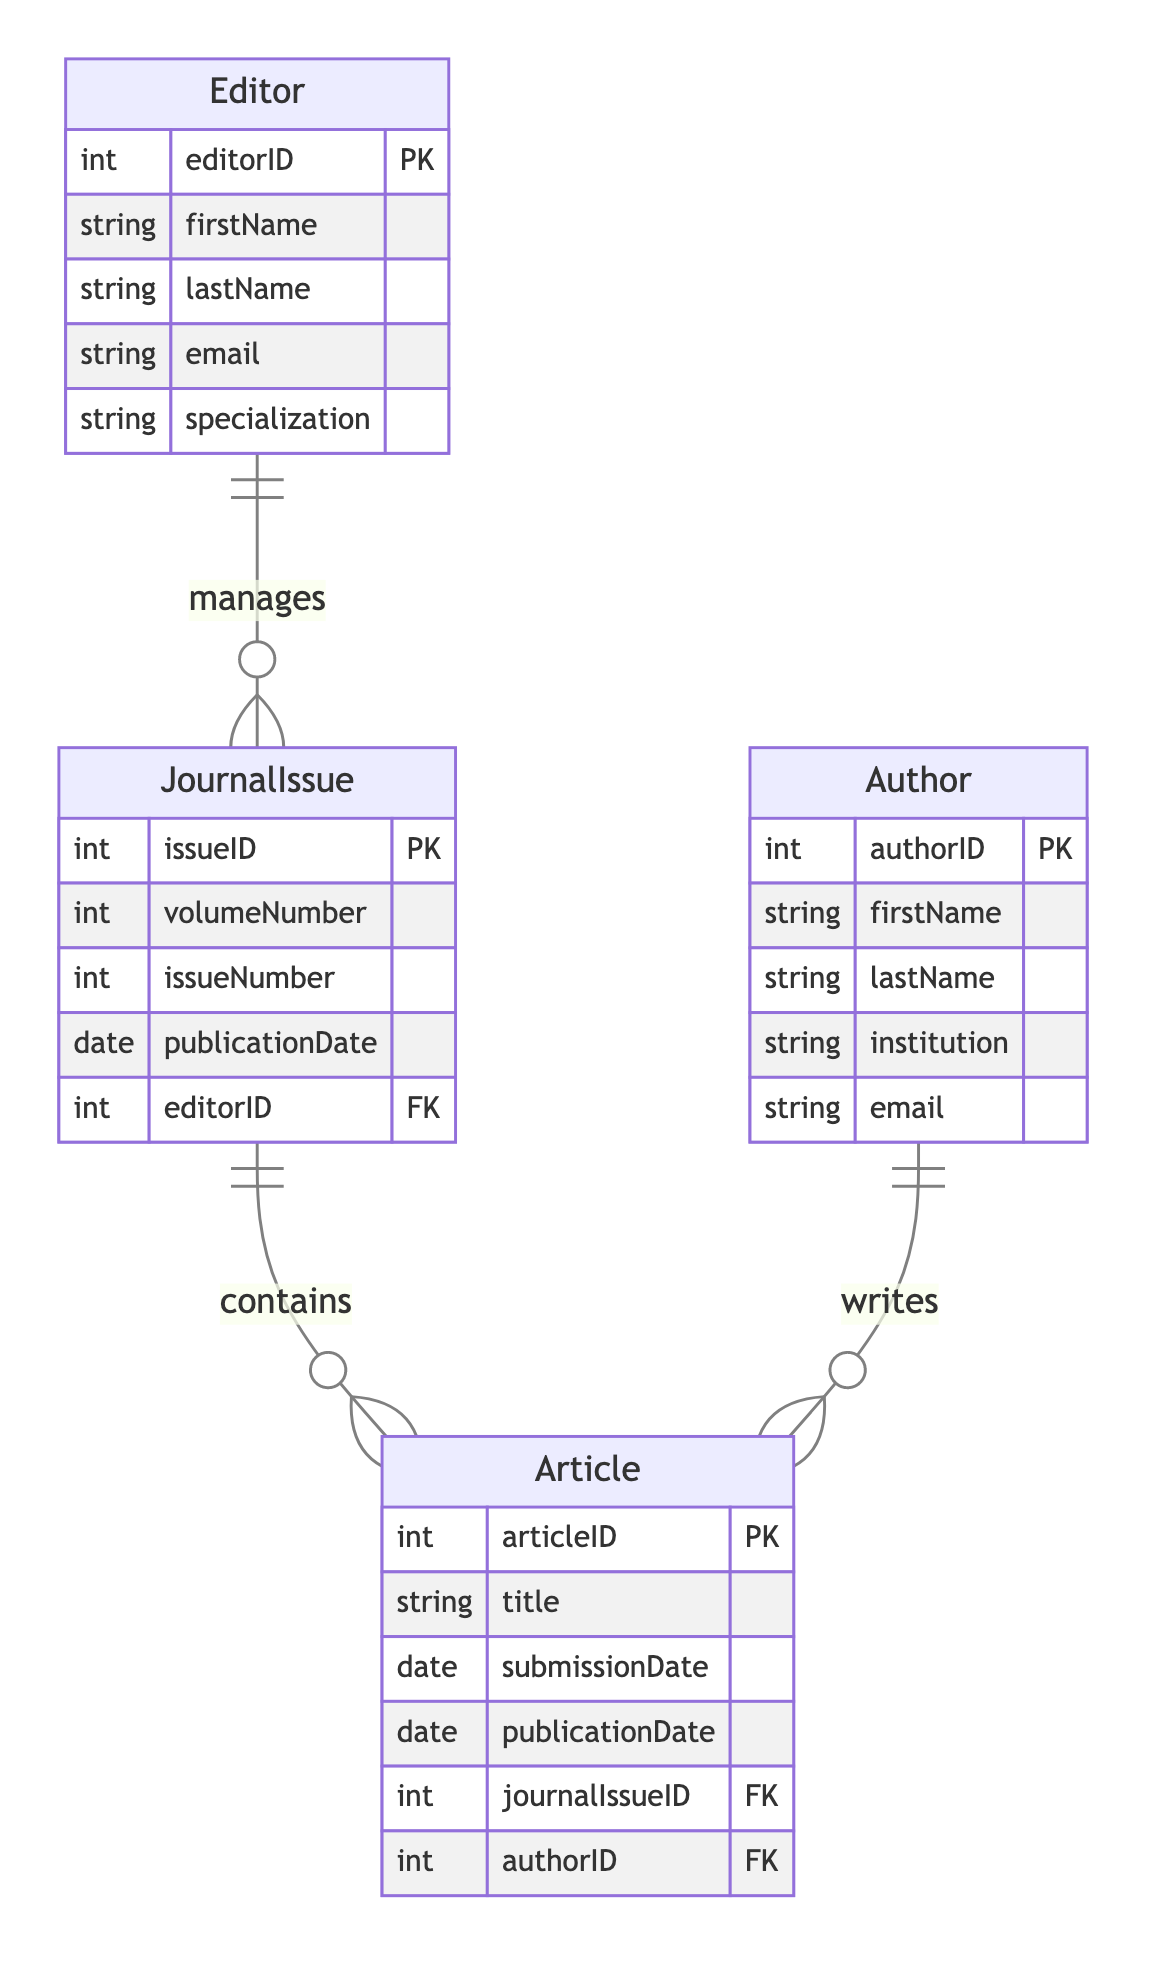What entities are present in the diagram? The diagram includes four entities: JournalIssue, Article, Author, and Editor.
Answer: JournalIssue, Article, Author, Editor How many attributes does the Article entity have? The Article entity has five attributes: articleID, title, submissionDate, publicationDate, and journalIssueID, and authorID.
Answer: Five What is the primary key for the Author entity? The primary key for the Author entity is authorID, which uniquely identifies each author in the database.
Answer: authorID What type of relationship exists between JournalIssue and Article? The relationship between JournalIssue and Article is a one-to-many relationship, indicating that one journal issue can contain multiple articles.
Answer: One-to-Many How many authors can write an article? An article can be written by one author, as indicated by the one-to-many relationship from Author to Article.
Answer: One Which entity manages the JournalIssu? The Editor entity manages the JournalIssue, as shown by the one-to-many relationship between Editor and JournalIssue.
Answer: Editor What foreign keys are present in the Article entity? The Article entity has two foreign keys: journalIssueID and authorID, linking it to the JournalIssue and Author entities, respectively.
Answer: journalIssueID, authorID Which attribute in the JournalIssue entity is used to track its publication date? The attribute used to track the publication date in the JournalIssue entity is publicationDate.
Answer: publicationDate How many articles can be associated with a single JournalIssue? A single JournalIssue can be associated with multiple articles, as indicated by the one-to-many relationship from JournalIssue to Article.
Answer: Multiple 